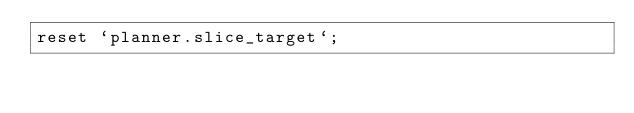<code> <loc_0><loc_0><loc_500><loc_500><_SQL_>reset `planner.slice_target`;
</code> 